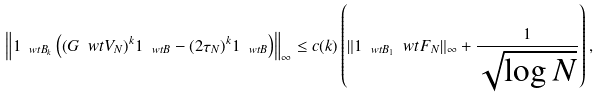Convert formula to latex. <formula><loc_0><loc_0><loc_500><loc_500>\left \| 1 _ { \ w t { B } _ { k } } \left ( ( G \ w t { V } _ { N } ) ^ { k } 1 _ { \ w t { B } } - ( 2 \tau _ { N } ) ^ { k } 1 _ { \ w t { B } } \right ) \right \| _ { \infty } \leq c ( k ) \left ( \| 1 _ { \ w t { B } _ { 1 } } \ w t { F } _ { N } \| _ { \infty } + \frac { 1 } { \sqrt { \log N } } \right ) ,</formula> 